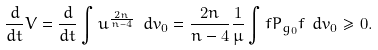Convert formula to latex. <formula><loc_0><loc_0><loc_500><loc_500>\frac { d } { d t } V = \frac { d } { d t } \int u ^ { \frac { 2 n } { n - 4 } } \ d v _ { 0 } = \frac { 2 n } { n - 4 } \frac { 1 } { \mu } \int f P _ { g _ { 0 } } f \ d v _ { 0 } \geq 0 .</formula> 